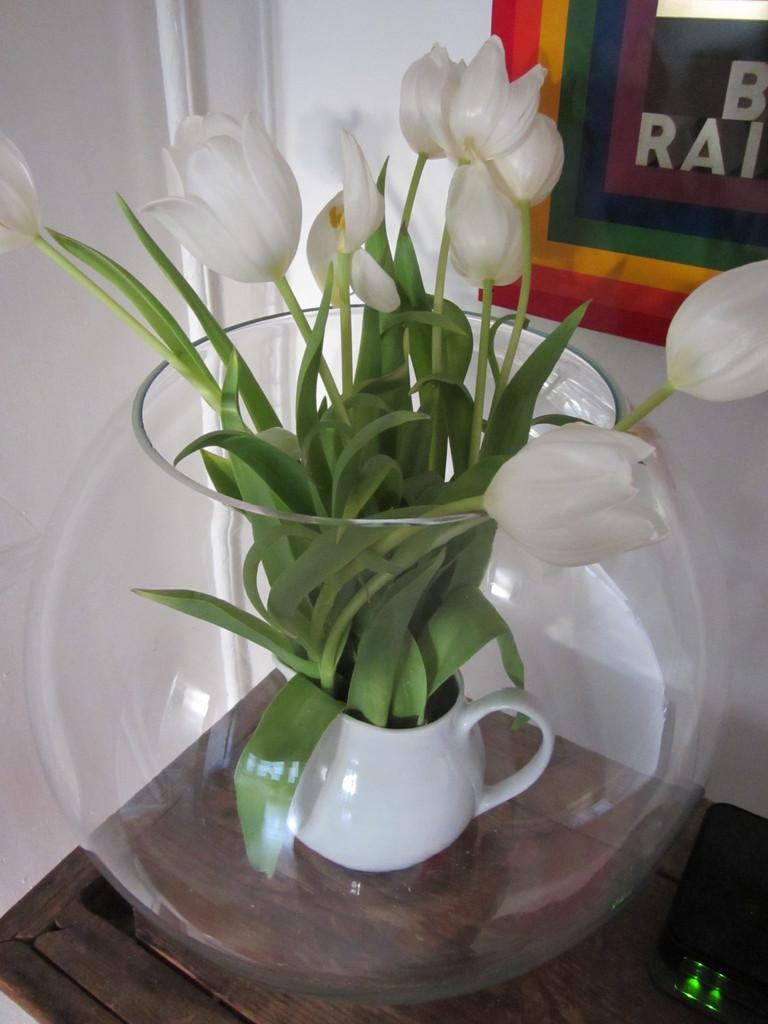What type of plant is visible in the image? There is a plant with flowers in the image. How is the plant contained or displayed? The plant is in a jar, which is inside a pot. Where is the pot located? The pot is placed on a table. What can be seen in the background of the image? There is a wall in the background of the image. What type of knot is used to secure the plant to the wall in the image? There is no knot visible in the image, as the plant is in a jar inside a pot on a table, and there is no indication of it being secured to the wall. 